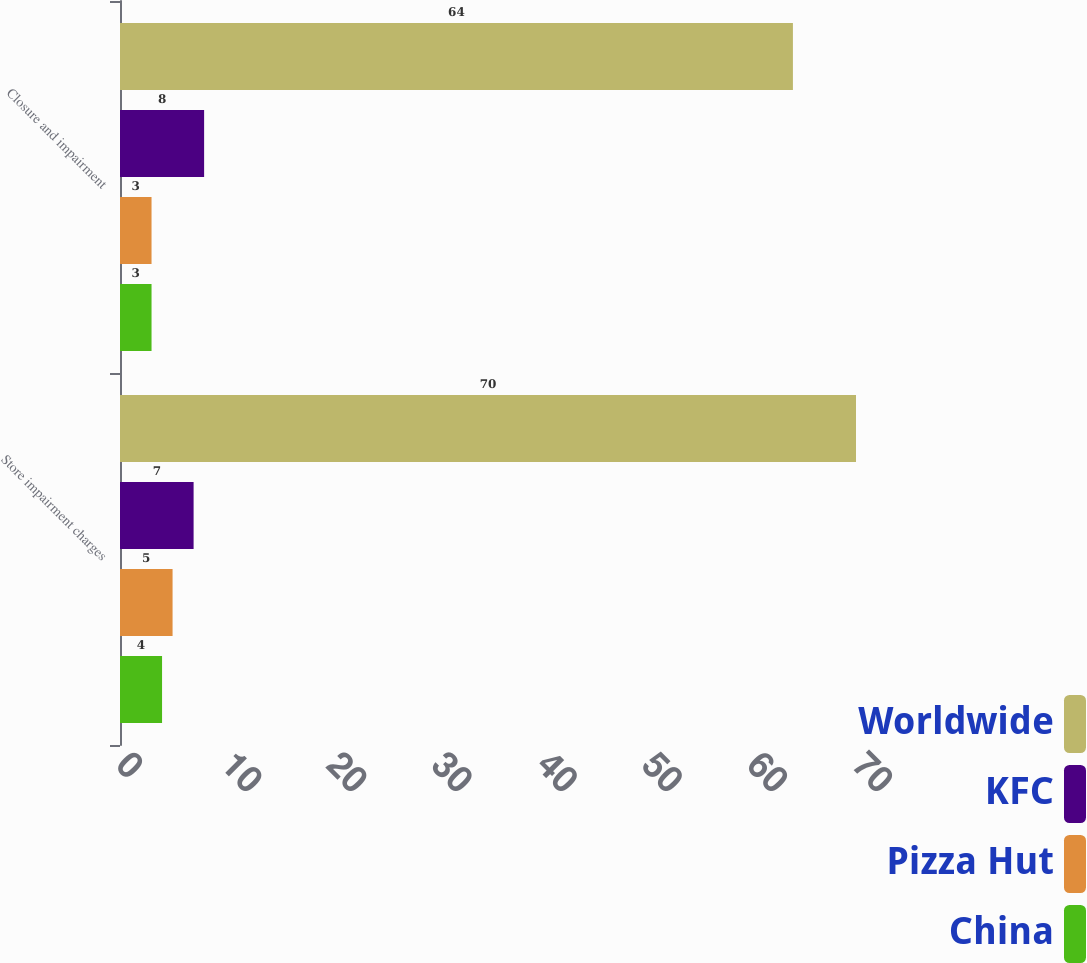<chart> <loc_0><loc_0><loc_500><loc_500><stacked_bar_chart><ecel><fcel>Store impairment charges<fcel>Closure and impairment<nl><fcel>Worldwide<fcel>70<fcel>64<nl><fcel>KFC<fcel>7<fcel>8<nl><fcel>Pizza Hut<fcel>5<fcel>3<nl><fcel>China<fcel>4<fcel>3<nl></chart> 